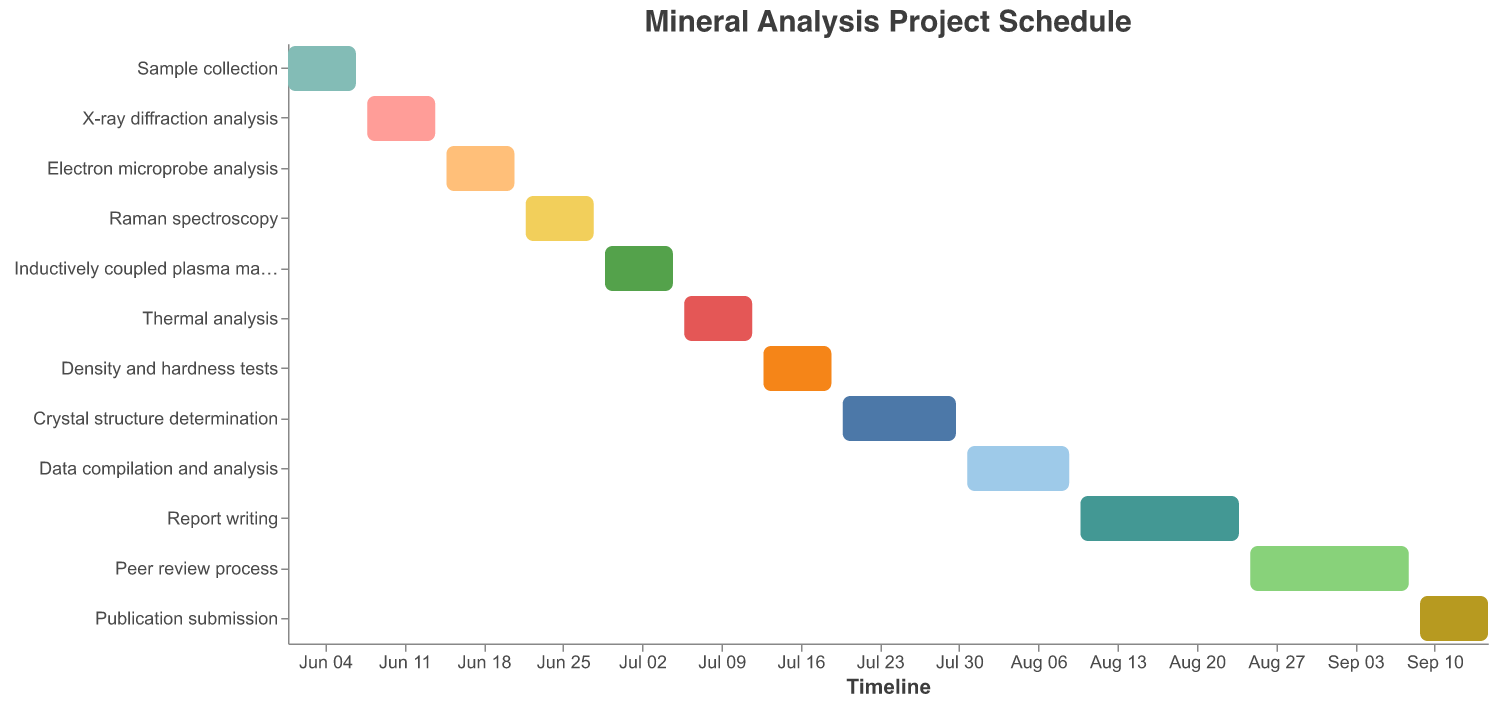What is the title of the Gantt chart? The title is positioned at the top of the Gantt chart, typically in a larger font size than other texts, for easy identification.
Answer: Mineral Analysis Project Schedule When does the "Thermal analysis" task start and end? In the Gantt chart, each task's start and end dates are visually represented along the timeline axis. For "Thermal analysis," the colored bar starts at "2023-07-06" and ends at "2023-07-12."
Answer: 2023-07-06 and 2023-07-12 What is the duration of the "Crystal structure determination" task? Each task's duration is explicitly mentioned in the tooltip and is also visually indicated by the length of the bar. The "Crystal structure determination" task lasts for 11 days, as shown in the tooltip and by the length of its bar.
Answer: 11 days Which tasks have the same duration? By comparing the lengths of the bars and the duration information in the tooltip, we see that "Sample collection," "X-ray diffraction analysis," "Electron microprobe analysis," "Raman spectroscopy," "Inductively coupled plasma mass spectrometry," "Thermal analysis," "Density and hardness tests," and "Publication submission" each have a duration of 7 days.
Answer: Eight tasks have the same duration Which task takes the longest to complete? By observing the lengths of the bars and duration values in the tooltip, the "Report writing" and "Peer review process" tasks each have the longest durations of 15 days.
Answer: Report writing and Peer review process How many days in total are planned for the project from start to end? Calculate the total duration from the beginning of the first task to the end of the last task. The project starts on "2023-06-01" and ends on "2023-09-15." The total span from start to end is (September 15 - June 1) = 107 days.
Answer: 107 days When does the "Data compilation and analysis" task start relative to "Crystal structure determination"? The start dates are visibile in the Gantt bars’ positions. Comparing them, "Data compilation and analysis" starts on "2023-07-31," right after "Crystal structure determination" ends on "2023-07-30." Thus, "Data compilation and analysis" starts the day after "Crystal structure determination" ends.
Answer: The next day What is the total duration for all analyses before compiling data and writing reports? Sum the durations of: "Sample collection" (7), "X-ray diffraction analysis" (7), "Electron microprobe analysis" (7), "Raman spectroscopy" (7), "Inductively coupled plasma mass spectrometry" (7), "Thermal analysis" (7), "Density and hardness tests" (7), "Crystal structure determination" (11). The total is 59 days.
Answer: 59 days Which analysis tasks are planned to start immediately after finishing another task? Each task starts the following day of the previous one ending, specifically: 
"X-ray diffraction analysis" after "Sample collection"; 
"Electron microprobe analysis" after "X-ray diffraction analysis"; 
"Raman spectroscopy" after "Electron microprobe analysis"; 
"Inductively coupled plasma mass spectrometry" after "Raman spectroscopy"; 
"Thermal analysis" after "Inductively coupled plasma mass spectrometry"; 
"Density and hardness tests" after "Thermal analysis"; 
"Crystal structure determination" after "Density and hardness tests."
Answer: Seven analysis tasks 